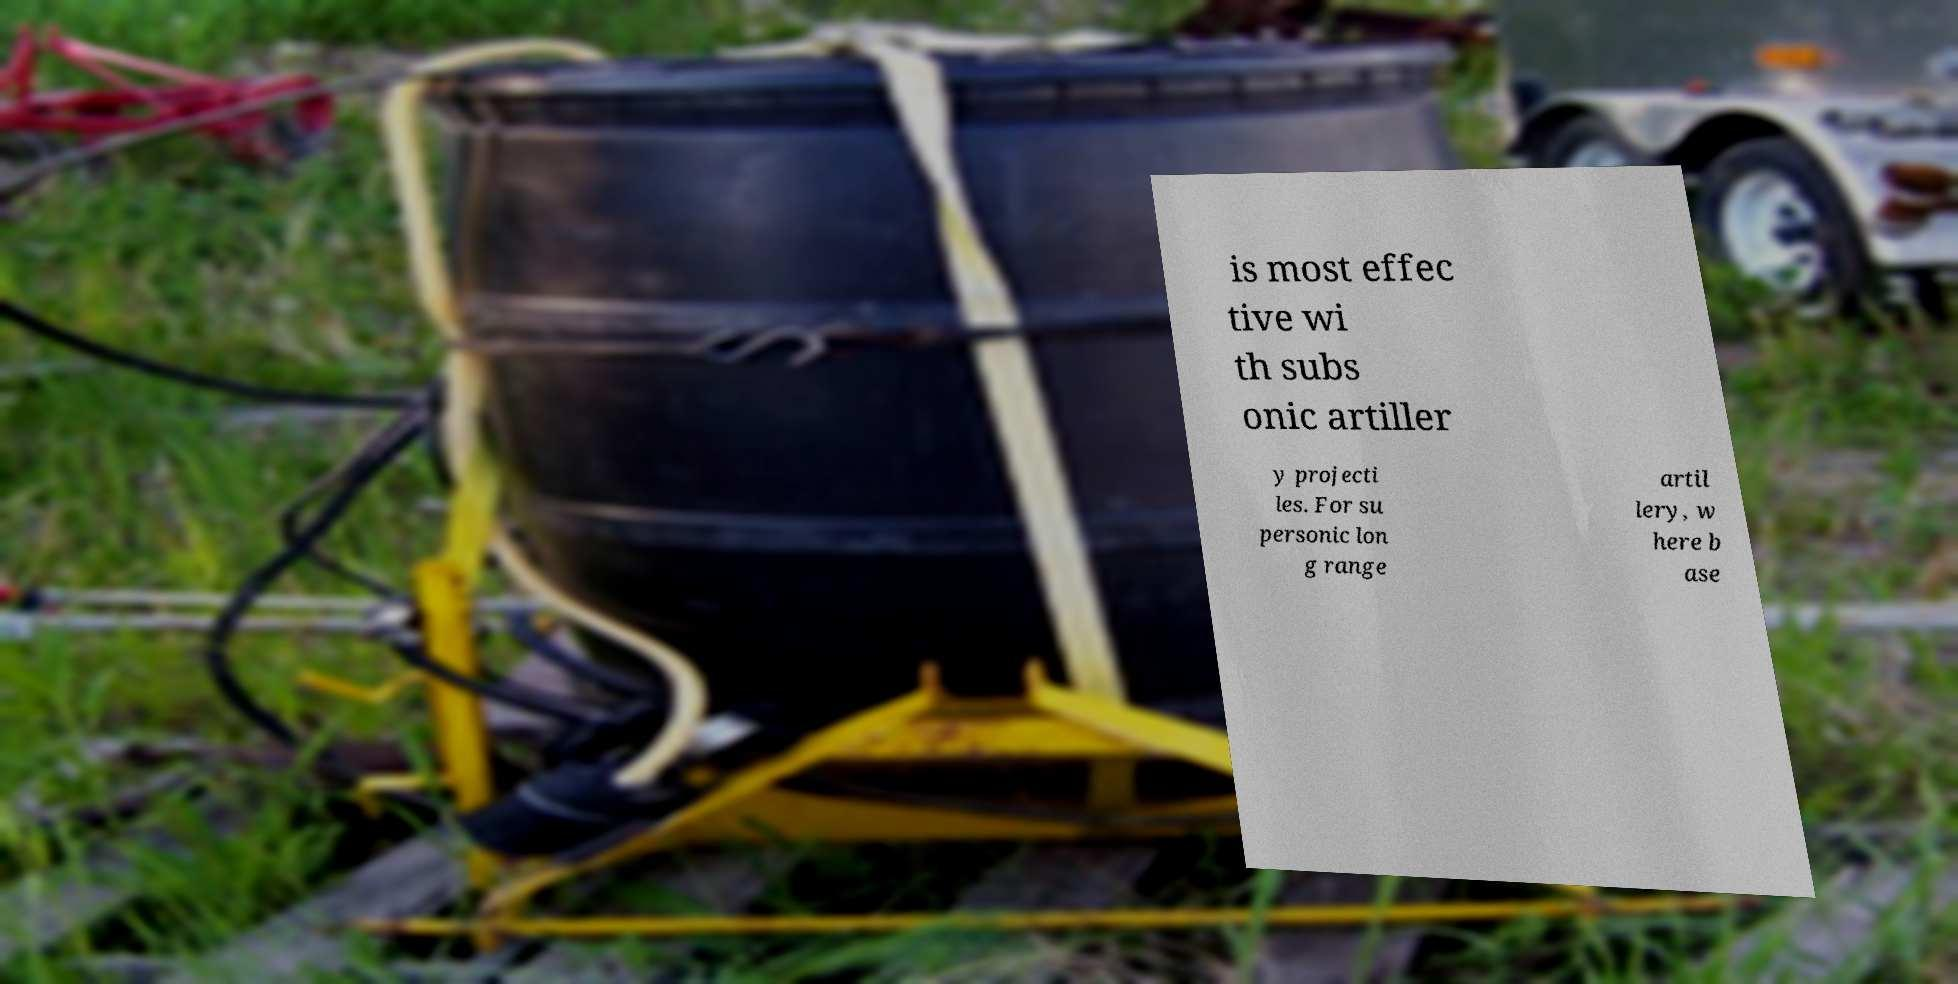Could you assist in decoding the text presented in this image and type it out clearly? is most effec tive wi th subs onic artiller y projecti les. For su personic lon g range artil lery, w here b ase 